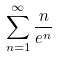Convert formula to latex. <formula><loc_0><loc_0><loc_500><loc_500>\sum _ { n = 1 } ^ { \infty } \frac { n } { e ^ { n } }</formula> 